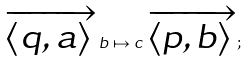Convert formula to latex. <formula><loc_0><loc_0><loc_500><loc_500>\overrightarrow { \langle q , a \rangle } \, b \mapsto c \, \overrightarrow { \langle p , b \rangle } ;</formula> 